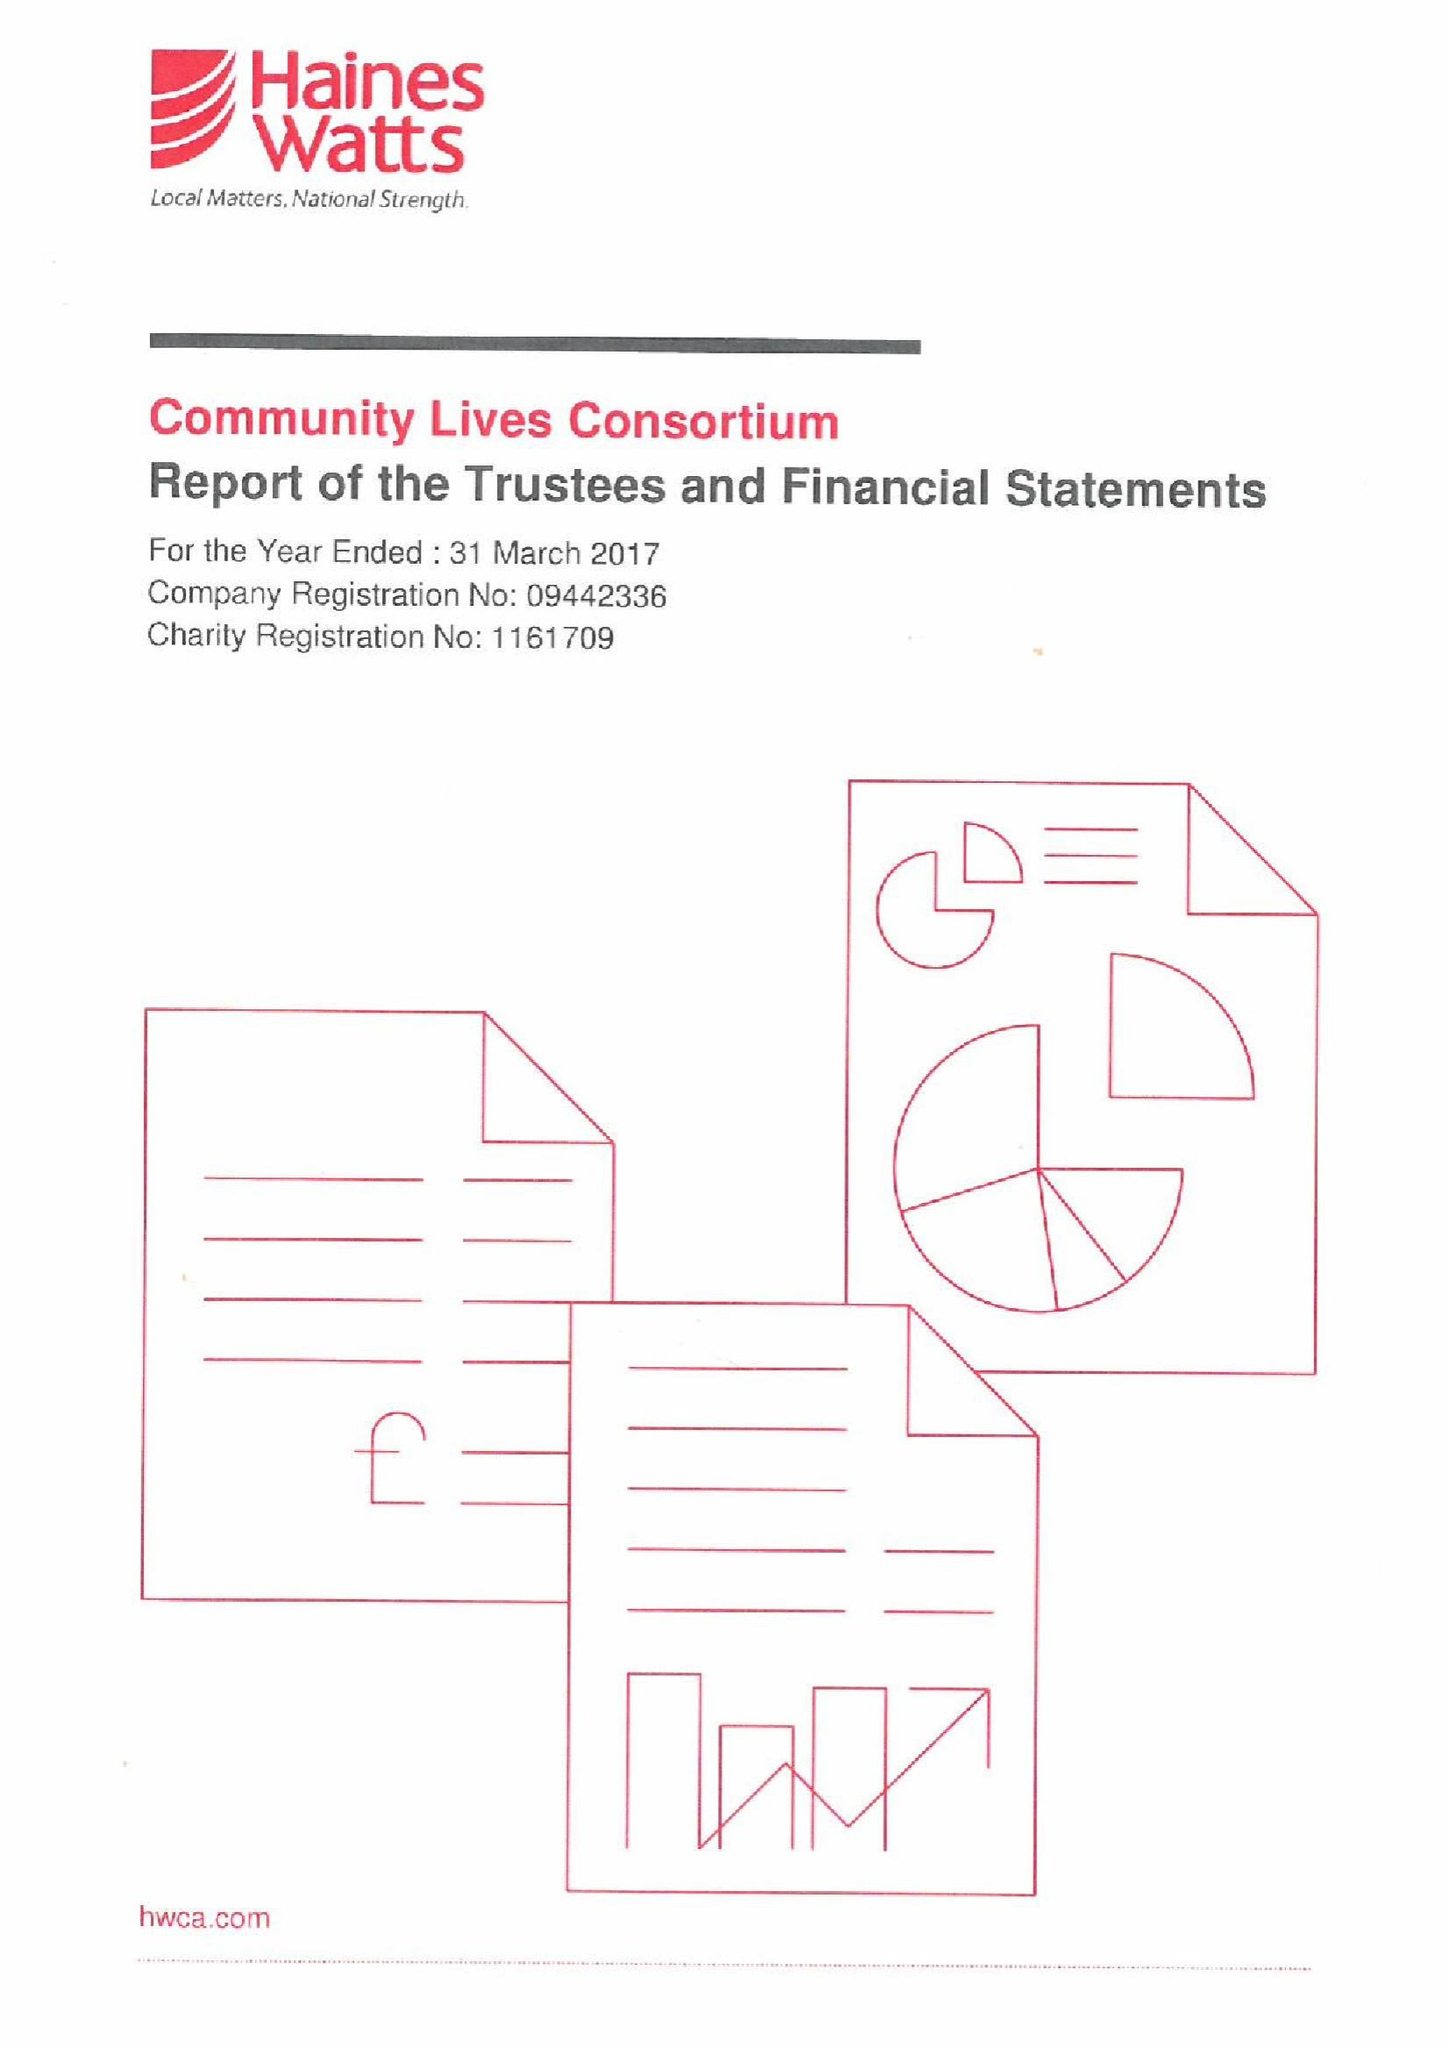What is the value for the charity_name?
Answer the question using a single word or phrase. Community Lives Consortium 